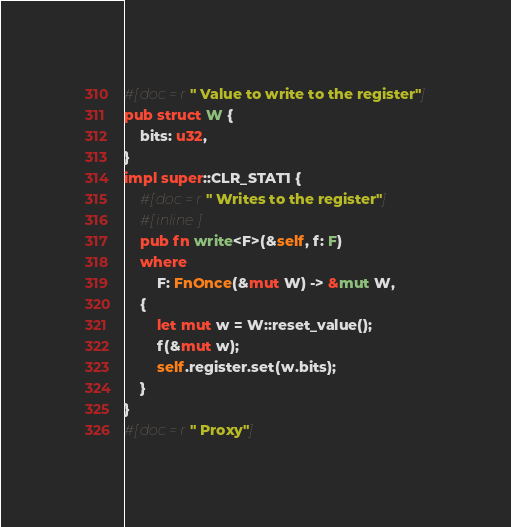<code> <loc_0><loc_0><loc_500><loc_500><_Rust_>#[doc = r" Value to write to the register"]
pub struct W {
    bits: u32,
}
impl super::CLR_STAT1 {
    #[doc = r" Writes to the register"]
    #[inline]
    pub fn write<F>(&self, f: F)
    where
        F: FnOnce(&mut W) -> &mut W,
    {
        let mut w = W::reset_value();
        f(&mut w);
        self.register.set(w.bits);
    }
}
#[doc = r" Proxy"]</code> 